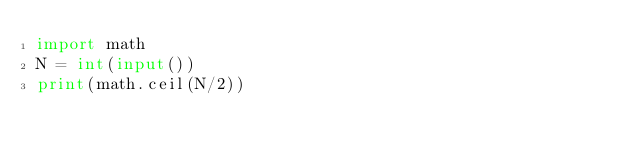<code> <loc_0><loc_0><loc_500><loc_500><_Python_>import math
N = int(input())
print(math.ceil(N/2))</code> 